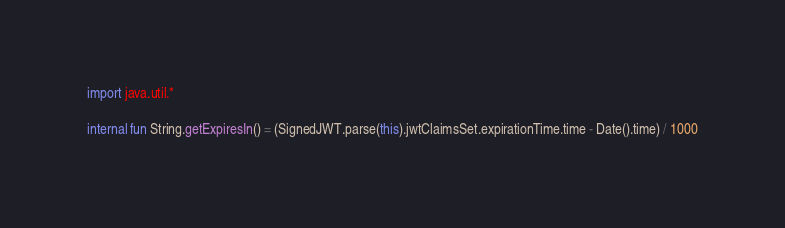Convert code to text. <code><loc_0><loc_0><loc_500><loc_500><_Kotlin_>import java.util.*

internal fun String.getExpiresIn() = (SignedJWT.parse(this).jwtClaimsSet.expirationTime.time - Date().time) / 1000</code> 